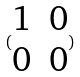Convert formula to latex. <formula><loc_0><loc_0><loc_500><loc_500>( \begin{matrix} 1 & 0 \\ 0 & 0 \end{matrix} )</formula> 